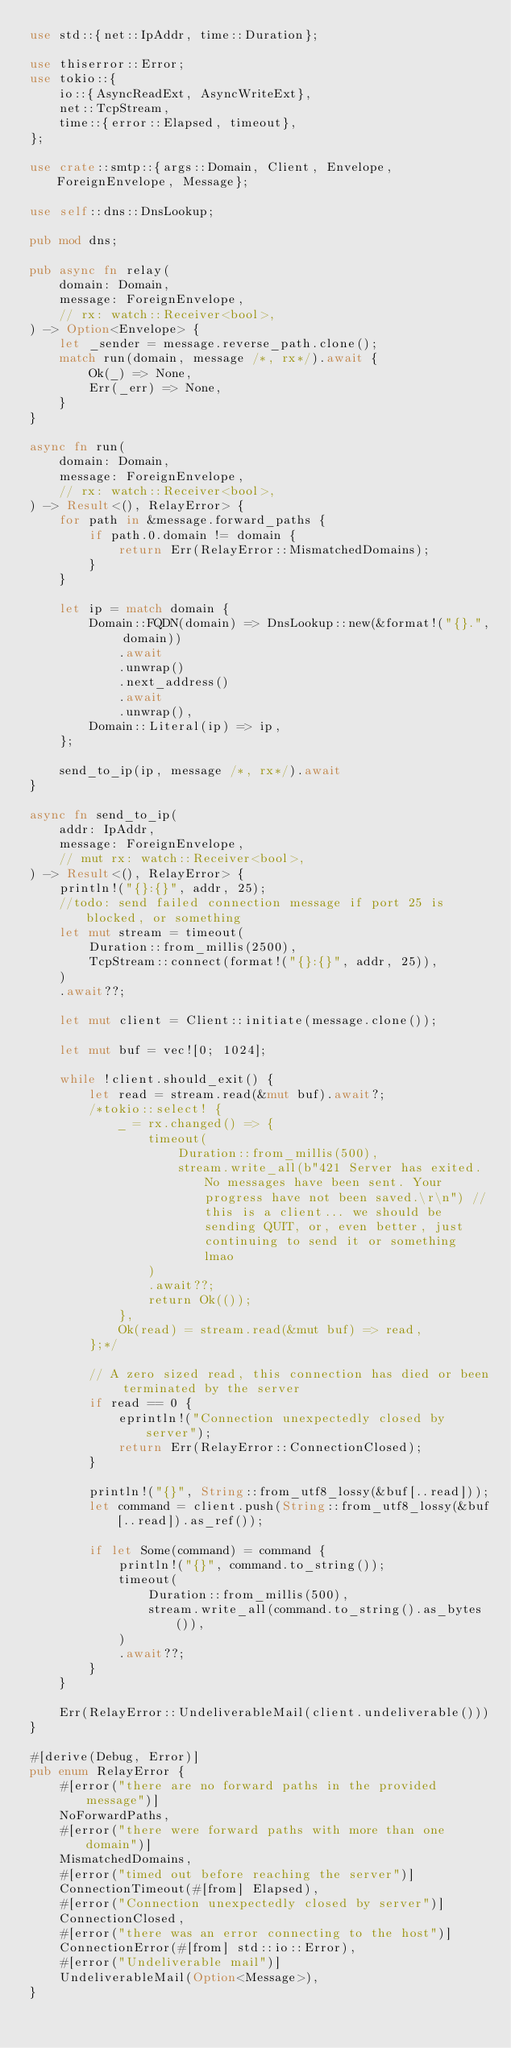<code> <loc_0><loc_0><loc_500><loc_500><_Rust_>use std::{net::IpAddr, time::Duration};

use thiserror::Error;
use tokio::{
	io::{AsyncReadExt, AsyncWriteExt},
	net::TcpStream,
	time::{error::Elapsed, timeout},
};

use crate::smtp::{args::Domain, Client, Envelope, ForeignEnvelope, Message};

use self::dns::DnsLookup;

pub mod dns;

pub async fn relay(
	domain: Domain,
	message: ForeignEnvelope,
	// rx: watch::Receiver<bool>,
) -> Option<Envelope> {
	let _sender = message.reverse_path.clone();
	match run(domain, message /*, rx*/).await {
		Ok(_) => None,
		Err(_err) => None,
	}
}

async fn run(
	domain: Domain,
	message: ForeignEnvelope,
	// rx: watch::Receiver<bool>,
) -> Result<(), RelayError> {
	for path in &message.forward_paths {
		if path.0.domain != domain {
			return Err(RelayError::MismatchedDomains);
		}
	}

	let ip = match domain {
		Domain::FQDN(domain) => DnsLookup::new(&format!("{}.", domain))
			.await
			.unwrap()
			.next_address()
			.await
			.unwrap(),
		Domain::Literal(ip) => ip,
	};

	send_to_ip(ip, message /*, rx*/).await
}

async fn send_to_ip(
	addr: IpAddr,
	message: ForeignEnvelope,
	// mut rx: watch::Receiver<bool>,
) -> Result<(), RelayError> {
	println!("{}:{}", addr, 25);
	//todo: send failed connection message if port 25 is blocked, or something
	let mut stream = timeout(
		Duration::from_millis(2500),
		TcpStream::connect(format!("{}:{}", addr, 25)),
	)
	.await??;

	let mut client = Client::initiate(message.clone());

	let mut buf = vec![0; 1024];

	while !client.should_exit() {
		let read = stream.read(&mut buf).await?;
		/*tokio::select! {
			_ = rx.changed() => {
				timeout(
					Duration::from_millis(500),
					stream.write_all(b"421 Server has exited. No messages have been sent. Your progress have not been saved.\r\n") //this is a client... we should be sending QUIT, or, even better, just continuing to send it or something lmao
				)
				.await??;
				return Ok(());
			},
			Ok(read) = stream.read(&mut buf) => read,
		};*/

		// A zero sized read, this connection has died or been terminated by the server
		if read == 0 {
			eprintln!("Connection unexpectedly closed by server");
			return Err(RelayError::ConnectionClosed);
		}

		println!("{}", String::from_utf8_lossy(&buf[..read]));
		let command = client.push(String::from_utf8_lossy(&buf[..read]).as_ref());

		if let Some(command) = command {
			println!("{}", command.to_string());
			timeout(
				Duration::from_millis(500),
				stream.write_all(command.to_string().as_bytes()),
			)
			.await??;
		}
	}

	Err(RelayError::UndeliverableMail(client.undeliverable()))
}

#[derive(Debug, Error)]
pub enum RelayError {
	#[error("there are no forward paths in the provided message")]
	NoForwardPaths,
	#[error("there were forward paths with more than one domain")]
	MismatchedDomains,
	#[error("timed out before reaching the server")]
	ConnectionTimeout(#[from] Elapsed),
	#[error("Connection unexpectedly closed by server")]
	ConnectionClosed,
	#[error("there was an error connecting to the host")]
	ConnectionError(#[from] std::io::Error),
	#[error("Undeliverable mail")]
	UndeliverableMail(Option<Message>),
}
</code> 